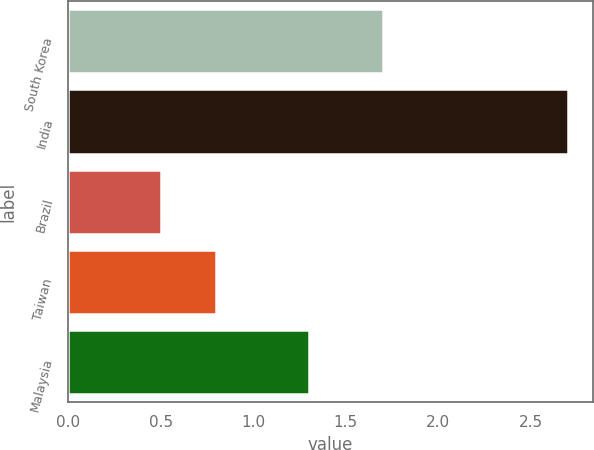Convert chart to OTSL. <chart><loc_0><loc_0><loc_500><loc_500><bar_chart><fcel>South Korea<fcel>India<fcel>Brazil<fcel>Taiwan<fcel>Malaysia<nl><fcel>1.7<fcel>2.7<fcel>0.5<fcel>0.8<fcel>1.3<nl></chart> 